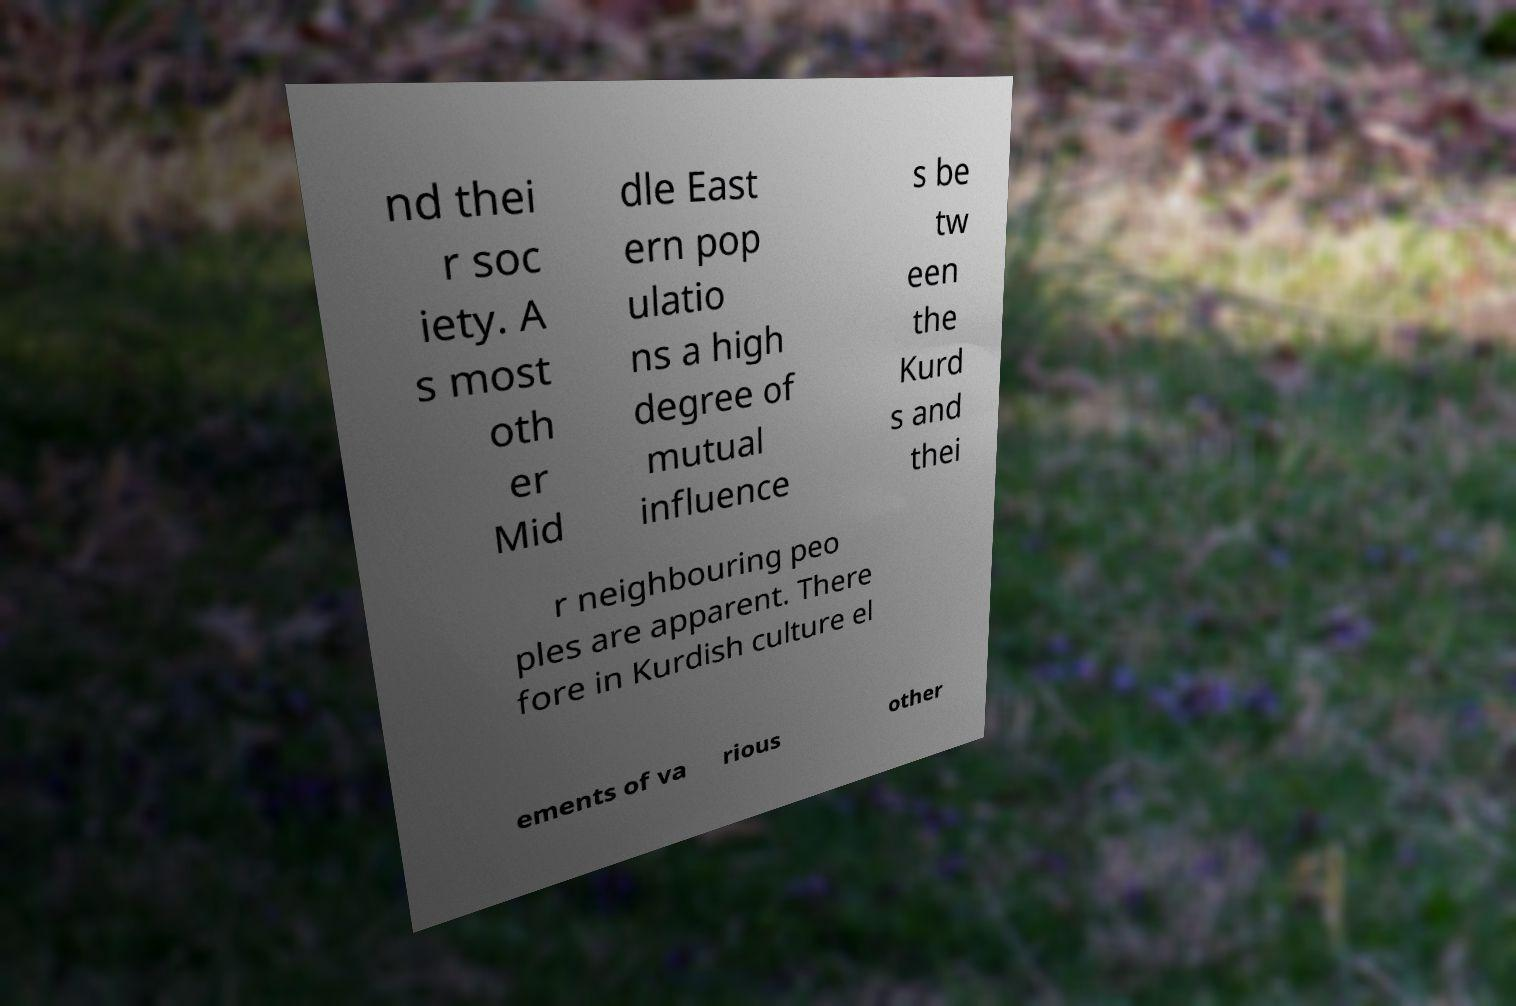Could you assist in decoding the text presented in this image and type it out clearly? nd thei r soc iety. A s most oth er Mid dle East ern pop ulatio ns a high degree of mutual influence s be tw een the Kurd s and thei r neighbouring peo ples are apparent. There fore in Kurdish culture el ements of va rious other 